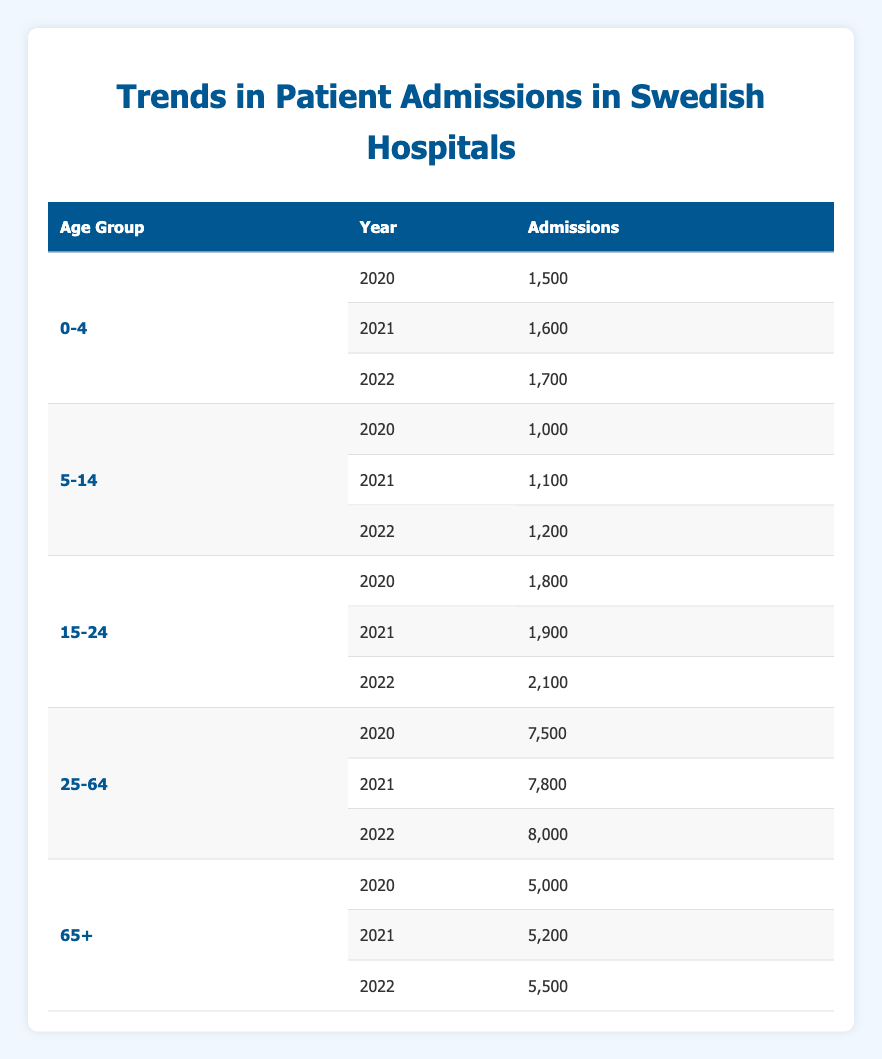What was the total number of patient admissions for age group 25-64 in 2021? To find the total admissions for age group 25-64 in 2021, we refer to the table entry for that age group and year, which shows 7,800 admissions.
Answer: 7,800 How many total admissions were recorded for all age groups in 2022? To calculate the total admissions for all age groups in 2022, we sum the admissions from each age group: 1,700 (0-4) + 1,200 (5-14) + 2,100 (15-24) + 8,000 (25-64) + 5,500 (65+) = 18,500.
Answer: 18,500 Is the number of admissions for age group 0-4 increasing over the years? Looking at the entries for age group 0-4, we see that admissions increased from 1,500 in 2020 to 1,600 in 2021, and then to 1,700 in 2022. This indicates a steady increase.
Answer: Yes What age group had the highest number of admissions in 2020? By comparing the admissions for all age groups in 2020, we find that the age group 25-64 had the highest number of admissions at 7,500.
Answer: 25-64 Calculate the percentage increase in admissions for age group 15-24 from 2020 to 2022. The admissions for age group 15-24 were 1,800 in 2020 and 2,100 in 2022. The increase is 2,100 - 1,800 = 300. To find the percentage increase, we use the formula (increase/original) * 100, which is (300/1,800) * 100 = 16.67%.
Answer: 16.67% Is it true that patient admissions for age group 65+ consistently increased over the years? Checking the entries for age group 65+, the admissions went from 5,000 in 2020 to 5,200 in 2021, and then to 5,500 in 2022, indicating a consistent increase in admissions.
Answer: Yes Which age group had the least number of admissions in 2021? By reviewing the 2021 admissions, the age group 5-14 recorded the least admissions at 1,100, compared to other age groups.
Answer: 5-14 What is the average number of admissions for all age groups in 2021? To find the average for 2021, we sum the admissions: 1,600 (0-4) + 1,100 (5-14) + 1,900 (15-24) + 7,800 (25-64) + 5,200 (65+) = 17,600. The average is then 17,600 divided by 5 age groups = 3,520.
Answer: 3,520 